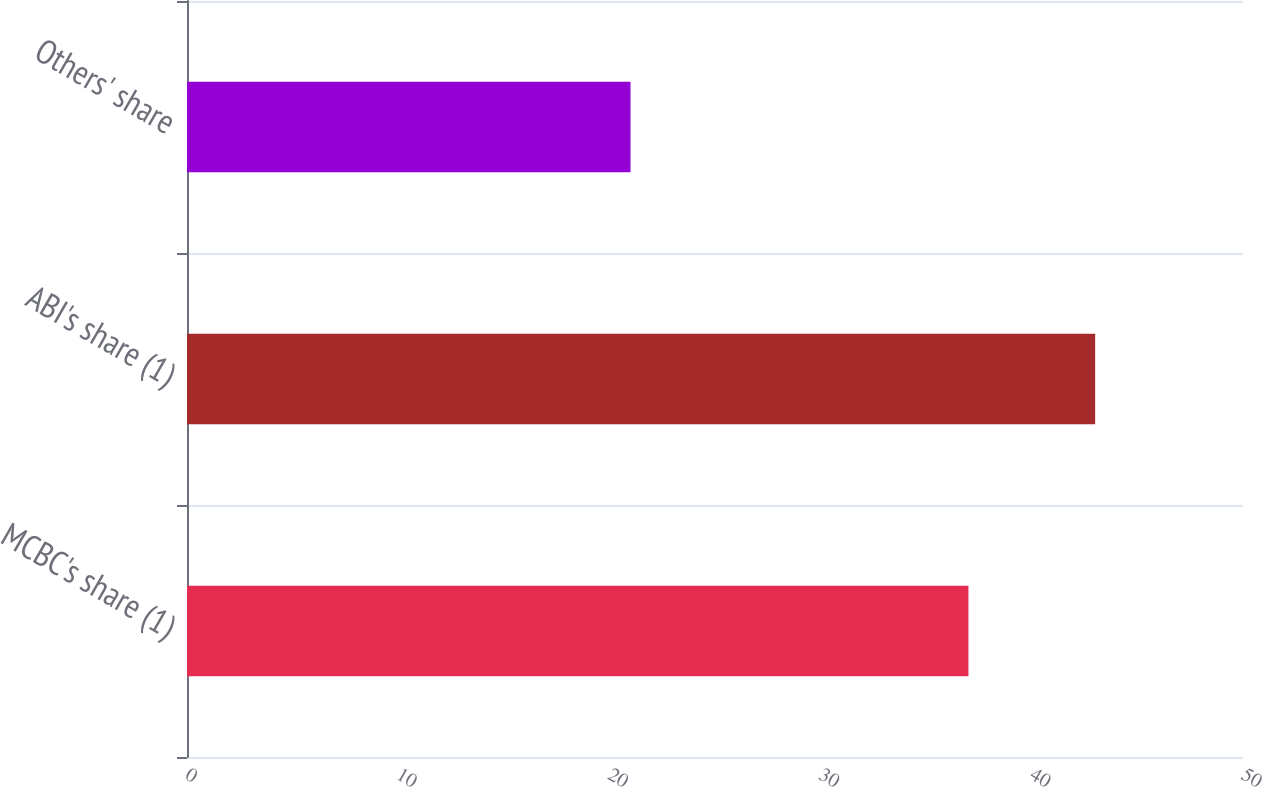Convert chart to OTSL. <chart><loc_0><loc_0><loc_500><loc_500><bar_chart><fcel>MCBC's share (1)<fcel>ABI's share (1)<fcel>Others' share<nl><fcel>37<fcel>43<fcel>21<nl></chart> 